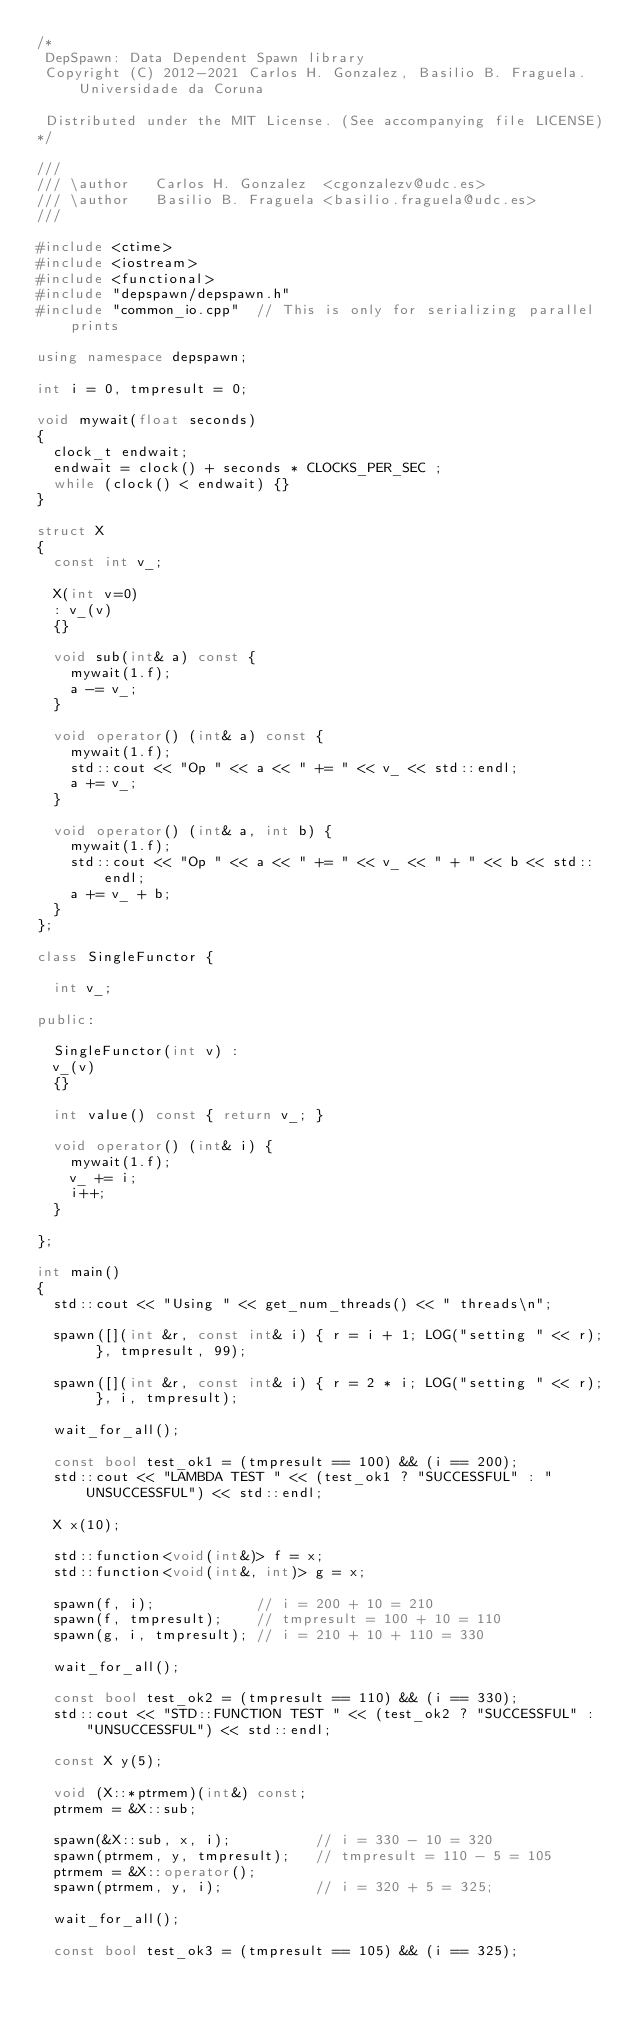<code> <loc_0><loc_0><loc_500><loc_500><_C++_>/*
 DepSpawn: Data Dependent Spawn library
 Copyright (C) 2012-2021 Carlos H. Gonzalez, Basilio B. Fraguela. Universidade da Coruna
 
 Distributed under the MIT License. (See accompanying file LICENSE)
*/

///
/// \author   Carlos H. Gonzalez  <cgonzalezv@udc.es>
/// \author   Basilio B. Fraguela <basilio.fraguela@udc.es>
///

#include <ctime>
#include <iostream>
#include <functional>
#include "depspawn/depspawn.h"
#include "common_io.cpp"  // This is only for serializing parallel prints

using namespace depspawn;

int i = 0, tmpresult = 0;

void mywait(float seconds)
{
  clock_t endwait;
  endwait = clock() + seconds * CLOCKS_PER_SEC ;
  while (clock() < endwait) {}
}

struct X
{
  const int v_;
  
  X(int v=0)
  : v_(v)
  {}
  
  void sub(int& a) const {
    mywait(1.f);
    a -= v_;
  }

  void operator() (int& a) const {
    mywait(1.f);
    std::cout << "Op " << a << " += " << v_ << std::endl;
    a += v_;
  }
 
  void operator() (int& a, int b) {
    mywait(1.f);
    std::cout << "Op " << a << " += " << v_ << " + " << b << std::endl;
    a += v_ + b;
  }
};

class SingleFunctor {

  int v_;

public:
  
  SingleFunctor(int v) :
  v_(v)
  {}
  
  int value() const { return v_; }
  
  void operator() (int& i) {
    mywait(1.f);
    v_ += i;
    i++;
  }
  
};

int main()
{
  std::cout << "Using " << get_num_threads() << " threads\n";

  spawn([](int &r, const int& i) { r = i + 1; LOG("setting " << r); }, tmpresult, 99);
  
  spawn([](int &r, const int& i) { r = 2 * i; LOG("setting " << r); }, i, tmpresult);
  
  wait_for_all();

  const bool test_ok1 = (tmpresult == 100) && (i == 200);
  std::cout << "LAMBDA TEST " << (test_ok1 ? "SUCCESSFUL" : "UNSUCCESSFUL") << std::endl;
  
  X x(10);
  
  std::function<void(int&)> f = x;
  std::function<void(int&, int)> g = x;
  
  spawn(f, i);            // i = 200 + 10 = 210
  spawn(f, tmpresult);    // tmpresult = 100 + 10 = 110
  spawn(g, i, tmpresult); // i = 210 + 10 + 110 = 330
  
  wait_for_all();
  
  const bool test_ok2 = (tmpresult == 110) && (i == 330);
  std::cout << "STD::FUNCTION TEST " << (test_ok2 ? "SUCCESSFUL" : "UNSUCCESSFUL") << std::endl;
  
  const X y(5);
  
  void (X::*ptrmem)(int&) const;
  ptrmem = &X::sub;
  
  spawn(&X::sub, x, i);          // i = 330 - 10 = 320
  spawn(ptrmem, y, tmpresult);   // tmpresult = 110 - 5 = 105
  ptrmem = &X::operator();
  spawn(ptrmem, y, i);           // i = 320 + 5 = 325;
  
  wait_for_all();
  
  const bool test_ok3 = (tmpresult == 105) && (i == 325);</code> 